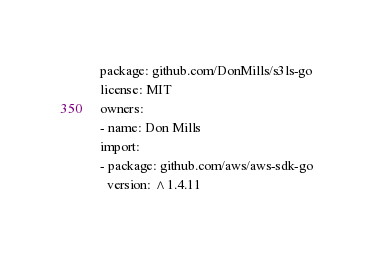Convert code to text. <code><loc_0><loc_0><loc_500><loc_500><_YAML_>package: github.com/DonMills/s3ls-go 
license: MIT
owners:
- name: Don Mills
import:
- package: github.com/aws/aws-sdk-go
  version: ^1.4.11
</code> 